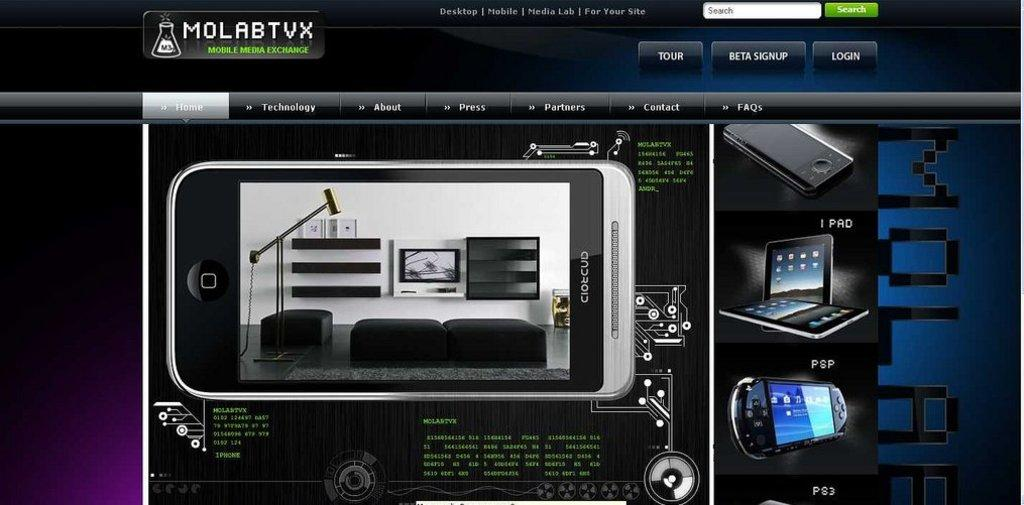<image>
Share a concise interpretation of the image provided. A webpage, entitled MolabTVX, shows the specifications of a phone. 